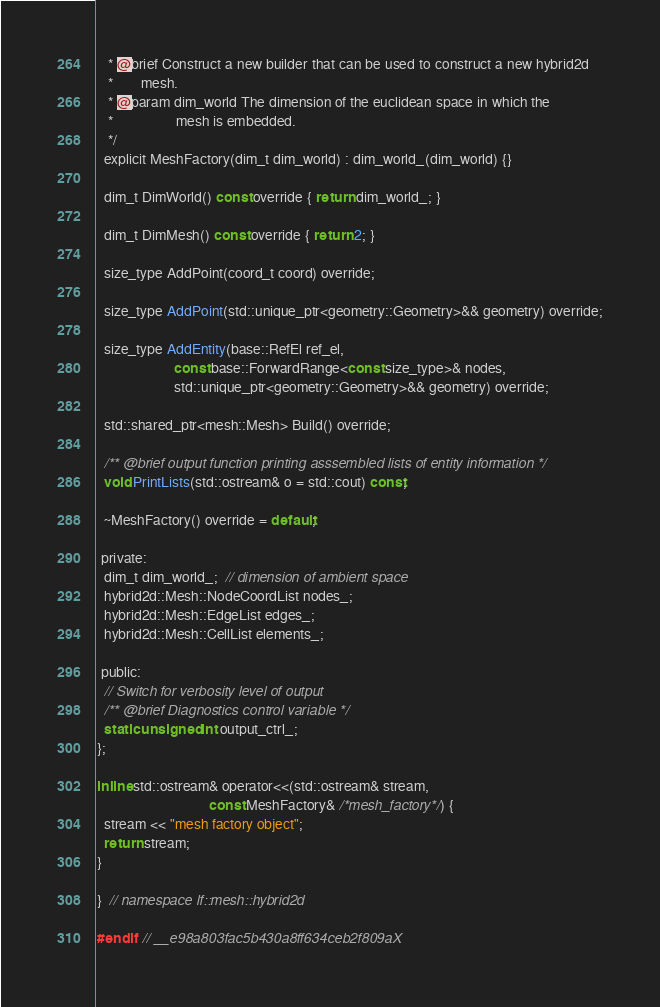Convert code to text. <code><loc_0><loc_0><loc_500><loc_500><_C_>   * @brief Construct a new builder that can be used to construct a new hybrid2d
   *        mesh.
   * @param dim_world The dimension of the euclidean space in which the
   *                  mesh is embedded.
   */
  explicit MeshFactory(dim_t dim_world) : dim_world_(dim_world) {}

  dim_t DimWorld() const override { return dim_world_; }

  dim_t DimMesh() const override { return 2; }

  size_type AddPoint(coord_t coord) override;

  size_type AddPoint(std::unique_ptr<geometry::Geometry>&& geometry) override;

  size_type AddEntity(base::RefEl ref_el,
                      const base::ForwardRange<const size_type>& nodes,
                      std::unique_ptr<geometry::Geometry>&& geometry) override;

  std::shared_ptr<mesh::Mesh> Build() override;

  /** @brief output function printing asssembled lists of entity information */
  void PrintLists(std::ostream& o = std::cout) const;

  ~MeshFactory() override = default;

 private:
  dim_t dim_world_;  // dimension of ambient space
  hybrid2d::Mesh::NodeCoordList nodes_;
  hybrid2d::Mesh::EdgeList edges_;
  hybrid2d::Mesh::CellList elements_;

 public:
  // Switch for verbosity level of output
  /** @brief Diagnostics control variable */
  static unsigned int output_ctrl_;
};

inline std::ostream& operator<<(std::ostream& stream,
                                const MeshFactory& /*mesh_factory*/) {
  stream << "mesh factory object";
  return stream;
}

}  // namespace lf::mesh::hybrid2d

#endif  // __e98a803fac5b430a8ff634ceb2f809aX
</code> 